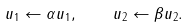<formula> <loc_0><loc_0><loc_500><loc_500>u _ { 1 } \leftarrow \alpha u _ { 1 } , \quad u _ { 2 } \leftarrow \beta u _ { 2 } .</formula> 